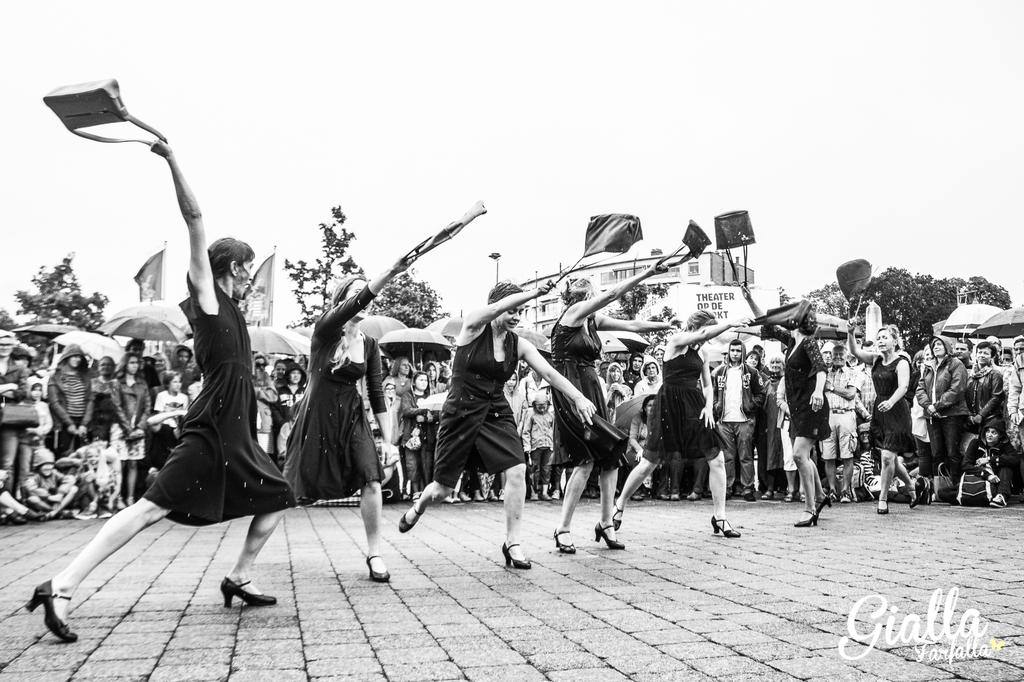What is the color scheme of the image? The image is black and white. What are the women in the image doing? The women are dancing in the image. What are the women holding while dancing? The women are holding handbags. Can you describe the setting of the image? There is a crowd around the dancing women, and some people in the crowd are holding umbrellas. Trees are visible in the background of the image. How many dinosaurs can be seen in the image? There are no dinosaurs present in the image. What direction are the women facing while dancing? The image is in black and white, and the direction the women are facing cannot be determined from the provided facts. 